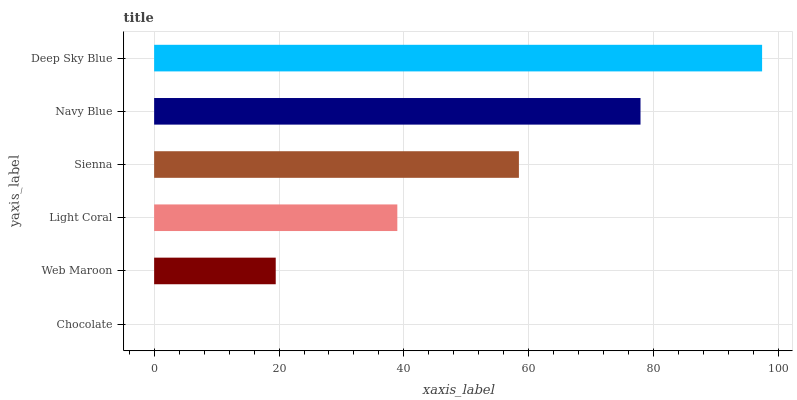Is Chocolate the minimum?
Answer yes or no. Yes. Is Deep Sky Blue the maximum?
Answer yes or no. Yes. Is Web Maroon the minimum?
Answer yes or no. No. Is Web Maroon the maximum?
Answer yes or no. No. Is Web Maroon greater than Chocolate?
Answer yes or no. Yes. Is Chocolate less than Web Maroon?
Answer yes or no. Yes. Is Chocolate greater than Web Maroon?
Answer yes or no. No. Is Web Maroon less than Chocolate?
Answer yes or no. No. Is Sienna the high median?
Answer yes or no. Yes. Is Light Coral the low median?
Answer yes or no. Yes. Is Light Coral the high median?
Answer yes or no. No. Is Web Maroon the low median?
Answer yes or no. No. 